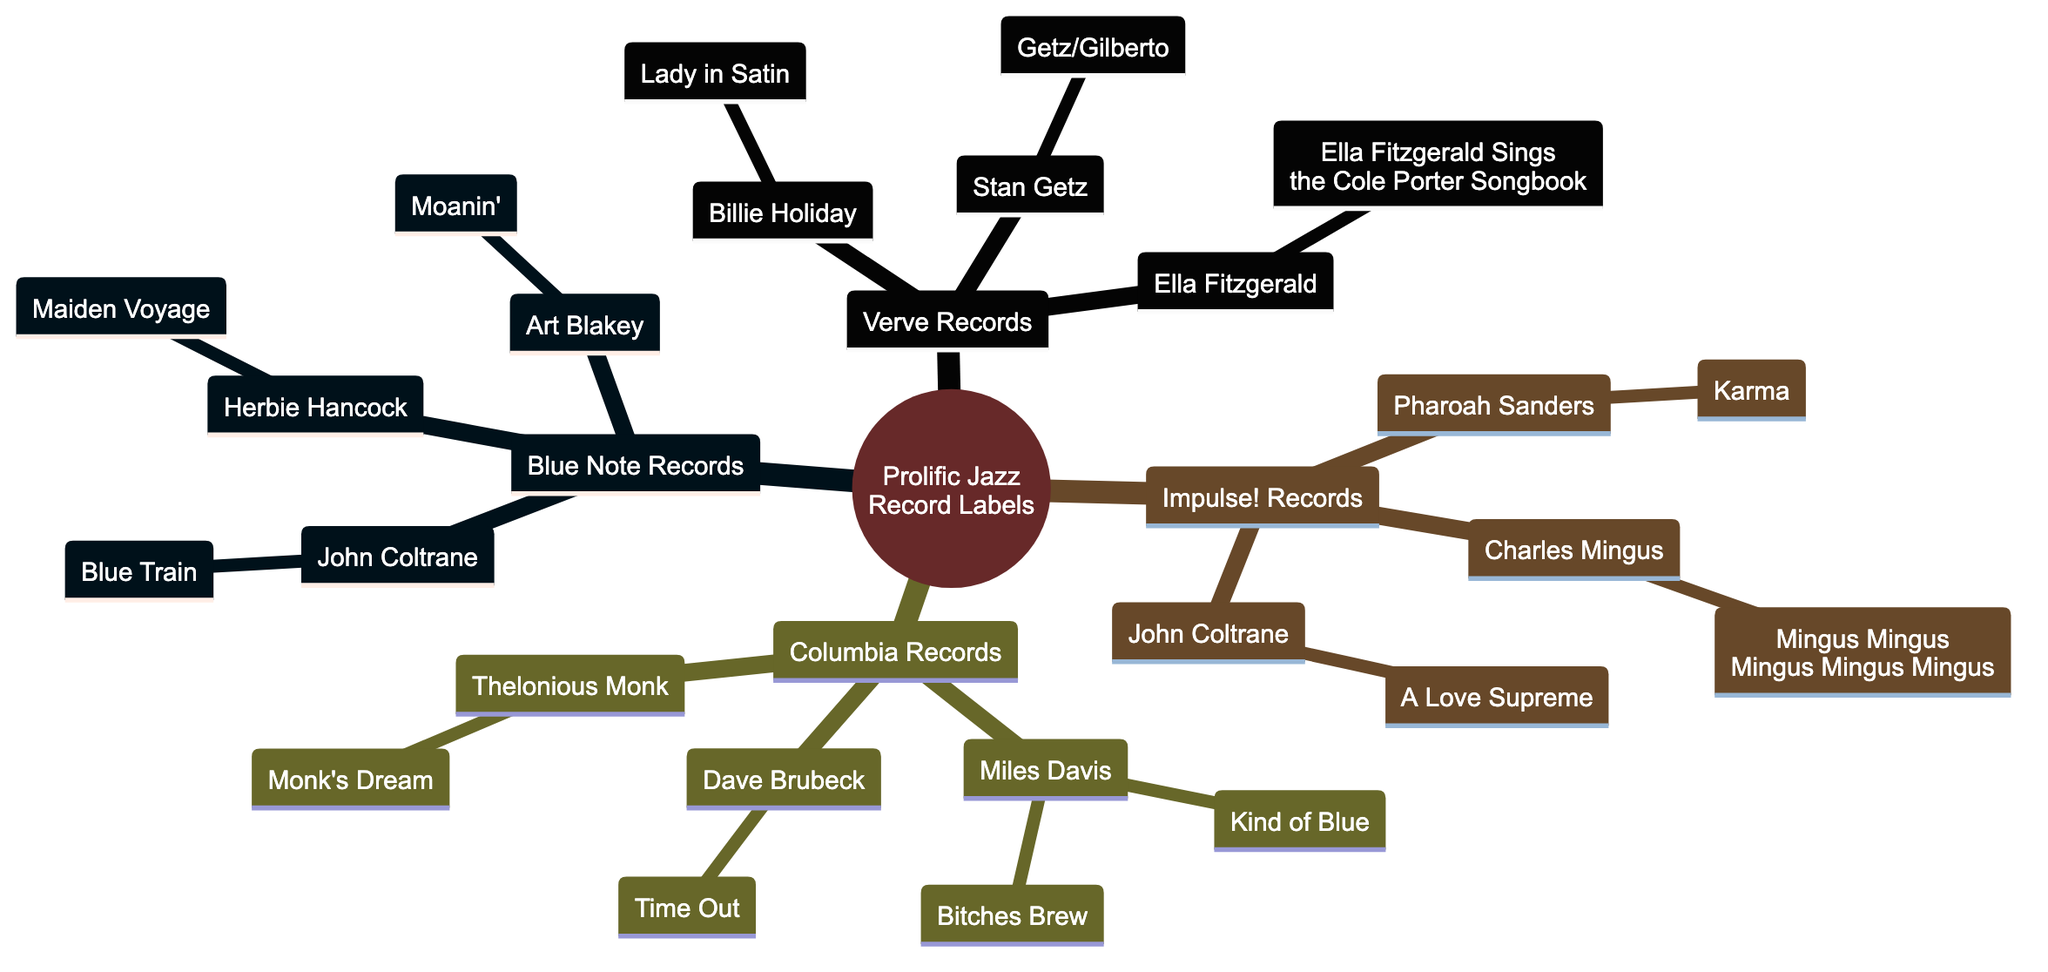What is the label of the first record label in the diagram? The first record label in the diagram is labeled "Blue Note Records", which can be found at the first position on the tree when reading from top to bottom.
Answer: Blue Note Records How many artists are signed under Verve Records? Under Verve Records, there are three listed artists: Billie Holiday, Ella Fitzgerald, and Stan Getz. The count of these nodes gives the answer.
Answer: 3 Which label has John Coltrane as an artist? John Coltrane appears under two labels in this diagram: Blue Note Records and Impulse! Records. Both instances can be observed as child nodes under these labels.
Answer: Blue Note Records, Impulse! Records What album is associated with Miles Davis? The albums associated with Miles Davis are "Kind of Blue" and "Bitches Brew", which can be seen listed as child nodes under Miles Davis within the Columbia Records section.
Answer: Kind of Blue, Bitches Brew Which artist has the album "A Love Supreme"? "A Love Supreme" is an album associated with John Coltrane, which is located under the Impulse! Records label in the diagram.
Answer: John Coltrane How many albums are listed under Blue Note Records? There are three albums listed under Blue Note Records: "Blue Train" (John Coltrane), "Maiden Voyage" (Herbie Hancock), and "Moanin'" (Art Blakey). Counting these gives the number of albums.
Answer: 3 Which artist is associated with the album "Getz/Gilberto"? The album "Getz/Gilberto" is associated with the artist Stan Getz, which can be identified as a child node under Verve Records in the diagram.
Answer: Stan Getz How many total jazz record labels are depicted in this family tree? The diagram depicts a total of four jazz record labels: Blue Note Records, Verve Records, Impulse! Records, and Columbia Records. The count can be easily recognized from the top-level nodes.
Answer: 4 Which artist has the most albums listed from the information provided? Miles Davis has the most albums listed, with two albums: "Kind of Blue" and "Bitches Brew" under Columbia Records. Comparing the number of albums for each artist shows that he leads.
Answer: Miles Davis 